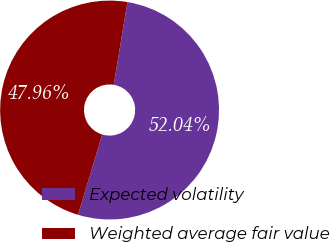Convert chart to OTSL. <chart><loc_0><loc_0><loc_500><loc_500><pie_chart><fcel>Expected volatility<fcel>Weighted average fair value<nl><fcel>52.04%<fcel>47.96%<nl></chart> 